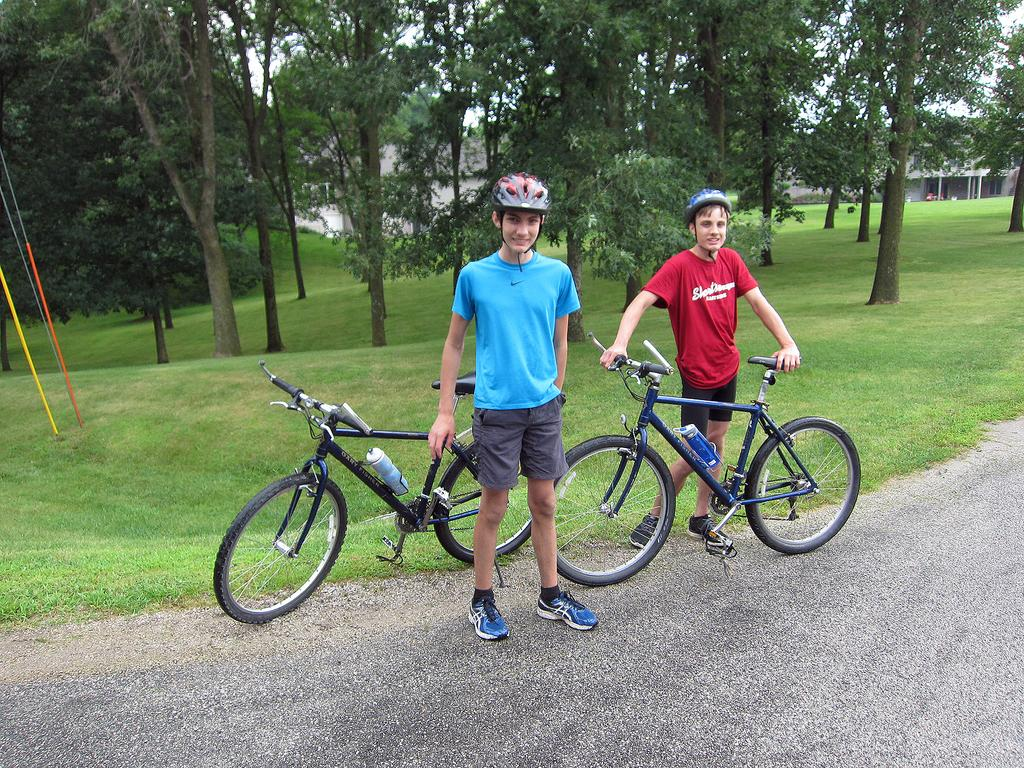What is the main subject in the center of the image? There are bicycles and persons on the road in the center of the image. What can be seen in the background of the image? There is grass, trees, buildings, water, and the sky visible in the background of the image. What type of toothpaste is being used by the persons on the road in the image? There is no toothpaste present in the image; it features bicycles and persons on the road. What operation is being performed on the bicycles in the image? There is no operation being performed on the bicycles in the image; they are simply being ridden by the persons on the road. 